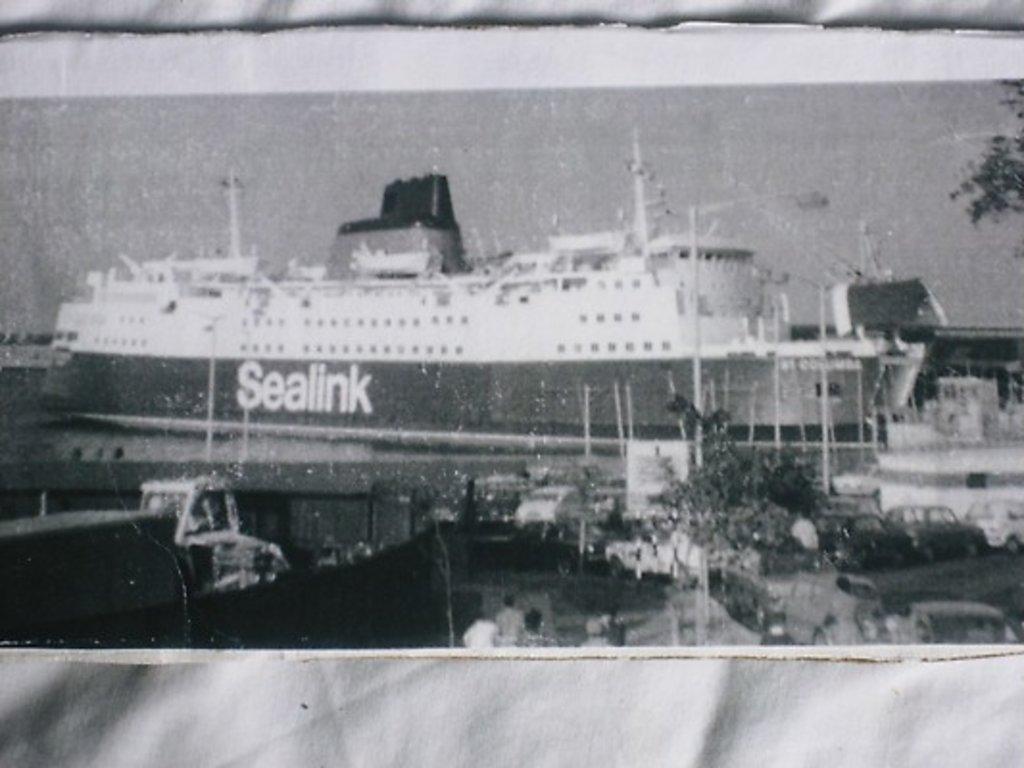How would you summarize this image in a sentence or two? This image consists of a paper with a black and white image on it. In the middle of the image there is a ship. At the bottom of the image there are a few people. On the left side of the image a few cars are parked on the road. On the left side of the image there is a truck. 